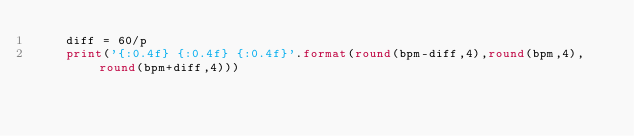Convert code to text. <code><loc_0><loc_0><loc_500><loc_500><_Python_>    diff = 60/p
    print('{:0.4f} {:0.4f} {:0.4f}'.format(round(bpm-diff,4),round(bpm,4),round(bpm+diff,4)))
</code> 